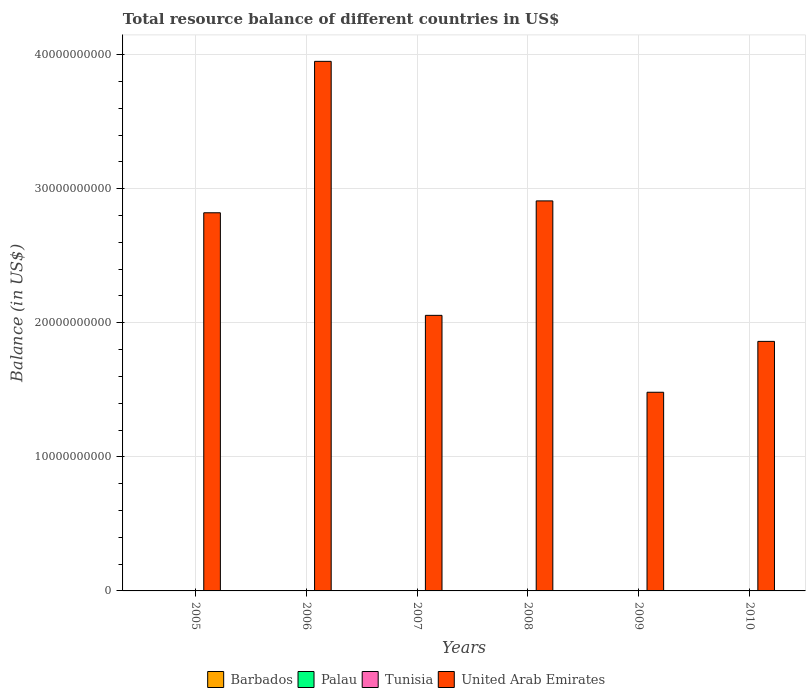Are the number of bars per tick equal to the number of legend labels?
Provide a succinct answer. No. How many bars are there on the 6th tick from the left?
Give a very brief answer. 1. How many bars are there on the 2nd tick from the right?
Your response must be concise. 1. What is the total resource balance in Tunisia in 2009?
Provide a short and direct response. 0. In which year was the total resource balance in United Arab Emirates maximum?
Provide a short and direct response. 2006. What is the difference between the total resource balance in United Arab Emirates in 2005 and that in 2007?
Provide a succinct answer. 7.65e+09. In how many years, is the total resource balance in Palau greater than 32000000000 US$?
Your answer should be very brief. 0. What is the ratio of the total resource balance in United Arab Emirates in 2005 to that in 2010?
Make the answer very short. 1.52. What is the difference between the highest and the second highest total resource balance in United Arab Emirates?
Your answer should be compact. 1.04e+1. What is the difference between the highest and the lowest total resource balance in United Arab Emirates?
Your answer should be compact. 2.47e+1. In how many years, is the total resource balance in Barbados greater than the average total resource balance in Barbados taken over all years?
Ensure brevity in your answer.  0. How many bars are there?
Ensure brevity in your answer.  6. Are all the bars in the graph horizontal?
Offer a terse response. No. Are the values on the major ticks of Y-axis written in scientific E-notation?
Give a very brief answer. No. Does the graph contain any zero values?
Keep it short and to the point. Yes. Does the graph contain grids?
Make the answer very short. Yes. What is the title of the graph?
Offer a very short reply. Total resource balance of different countries in US$. Does "Tonga" appear as one of the legend labels in the graph?
Your answer should be very brief. No. What is the label or title of the Y-axis?
Ensure brevity in your answer.  Balance (in US$). What is the Balance (in US$) in United Arab Emirates in 2005?
Ensure brevity in your answer.  2.82e+1. What is the Balance (in US$) of Barbados in 2006?
Provide a succinct answer. 0. What is the Balance (in US$) of United Arab Emirates in 2006?
Your answer should be compact. 3.95e+1. What is the Balance (in US$) in Tunisia in 2007?
Offer a terse response. 0. What is the Balance (in US$) in United Arab Emirates in 2007?
Provide a short and direct response. 2.06e+1. What is the Balance (in US$) of Barbados in 2008?
Offer a very short reply. 0. What is the Balance (in US$) in Palau in 2008?
Provide a succinct answer. 0. What is the Balance (in US$) in United Arab Emirates in 2008?
Offer a very short reply. 2.91e+1. What is the Balance (in US$) of Barbados in 2009?
Make the answer very short. 0. What is the Balance (in US$) of Palau in 2009?
Your answer should be compact. 0. What is the Balance (in US$) of Tunisia in 2009?
Keep it short and to the point. 0. What is the Balance (in US$) in United Arab Emirates in 2009?
Offer a very short reply. 1.48e+1. What is the Balance (in US$) in Barbados in 2010?
Provide a succinct answer. 0. What is the Balance (in US$) of Palau in 2010?
Offer a very short reply. 0. What is the Balance (in US$) in United Arab Emirates in 2010?
Give a very brief answer. 1.86e+1. Across all years, what is the maximum Balance (in US$) in United Arab Emirates?
Give a very brief answer. 3.95e+1. Across all years, what is the minimum Balance (in US$) of United Arab Emirates?
Your response must be concise. 1.48e+1. What is the total Balance (in US$) of Tunisia in the graph?
Provide a short and direct response. 0. What is the total Balance (in US$) of United Arab Emirates in the graph?
Your answer should be compact. 1.51e+11. What is the difference between the Balance (in US$) in United Arab Emirates in 2005 and that in 2006?
Your response must be concise. -1.13e+1. What is the difference between the Balance (in US$) in United Arab Emirates in 2005 and that in 2007?
Offer a terse response. 7.65e+09. What is the difference between the Balance (in US$) in United Arab Emirates in 2005 and that in 2008?
Keep it short and to the point. -8.86e+08. What is the difference between the Balance (in US$) of United Arab Emirates in 2005 and that in 2009?
Ensure brevity in your answer.  1.34e+1. What is the difference between the Balance (in US$) in United Arab Emirates in 2005 and that in 2010?
Give a very brief answer. 9.59e+09. What is the difference between the Balance (in US$) in United Arab Emirates in 2006 and that in 2007?
Provide a short and direct response. 1.89e+1. What is the difference between the Balance (in US$) of United Arab Emirates in 2006 and that in 2008?
Ensure brevity in your answer.  1.04e+1. What is the difference between the Balance (in US$) in United Arab Emirates in 2006 and that in 2009?
Offer a terse response. 2.47e+1. What is the difference between the Balance (in US$) of United Arab Emirates in 2006 and that in 2010?
Ensure brevity in your answer.  2.09e+1. What is the difference between the Balance (in US$) in United Arab Emirates in 2007 and that in 2008?
Give a very brief answer. -8.54e+09. What is the difference between the Balance (in US$) of United Arab Emirates in 2007 and that in 2009?
Ensure brevity in your answer.  5.74e+09. What is the difference between the Balance (in US$) in United Arab Emirates in 2007 and that in 2010?
Ensure brevity in your answer.  1.94e+09. What is the difference between the Balance (in US$) in United Arab Emirates in 2008 and that in 2009?
Provide a succinct answer. 1.43e+1. What is the difference between the Balance (in US$) of United Arab Emirates in 2008 and that in 2010?
Offer a very short reply. 1.05e+1. What is the difference between the Balance (in US$) of United Arab Emirates in 2009 and that in 2010?
Offer a very short reply. -3.79e+09. What is the average Balance (in US$) in Palau per year?
Make the answer very short. 0. What is the average Balance (in US$) in United Arab Emirates per year?
Give a very brief answer. 2.51e+1. What is the ratio of the Balance (in US$) of United Arab Emirates in 2005 to that in 2006?
Provide a short and direct response. 0.71. What is the ratio of the Balance (in US$) in United Arab Emirates in 2005 to that in 2007?
Offer a terse response. 1.37. What is the ratio of the Balance (in US$) of United Arab Emirates in 2005 to that in 2008?
Provide a succinct answer. 0.97. What is the ratio of the Balance (in US$) of United Arab Emirates in 2005 to that in 2009?
Offer a very short reply. 1.9. What is the ratio of the Balance (in US$) of United Arab Emirates in 2005 to that in 2010?
Your answer should be compact. 1.52. What is the ratio of the Balance (in US$) in United Arab Emirates in 2006 to that in 2007?
Your response must be concise. 1.92. What is the ratio of the Balance (in US$) of United Arab Emirates in 2006 to that in 2008?
Give a very brief answer. 1.36. What is the ratio of the Balance (in US$) in United Arab Emirates in 2006 to that in 2009?
Keep it short and to the point. 2.67. What is the ratio of the Balance (in US$) in United Arab Emirates in 2006 to that in 2010?
Offer a very short reply. 2.12. What is the ratio of the Balance (in US$) of United Arab Emirates in 2007 to that in 2008?
Offer a very short reply. 0.71. What is the ratio of the Balance (in US$) in United Arab Emirates in 2007 to that in 2009?
Keep it short and to the point. 1.39. What is the ratio of the Balance (in US$) in United Arab Emirates in 2007 to that in 2010?
Your response must be concise. 1.1. What is the ratio of the Balance (in US$) in United Arab Emirates in 2008 to that in 2009?
Your answer should be very brief. 1.96. What is the ratio of the Balance (in US$) in United Arab Emirates in 2008 to that in 2010?
Keep it short and to the point. 1.56. What is the ratio of the Balance (in US$) of United Arab Emirates in 2009 to that in 2010?
Offer a very short reply. 0.8. What is the difference between the highest and the second highest Balance (in US$) of United Arab Emirates?
Make the answer very short. 1.04e+1. What is the difference between the highest and the lowest Balance (in US$) in United Arab Emirates?
Your response must be concise. 2.47e+1. 